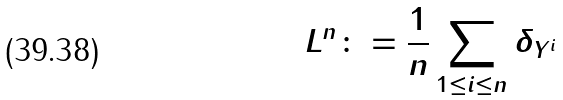Convert formula to latex. <formula><loc_0><loc_0><loc_500><loc_500>L ^ { n } \colon = \frac { 1 } { n } \sum _ { 1 \leq i \leq n } \delta _ { Y ^ { i } }</formula> 